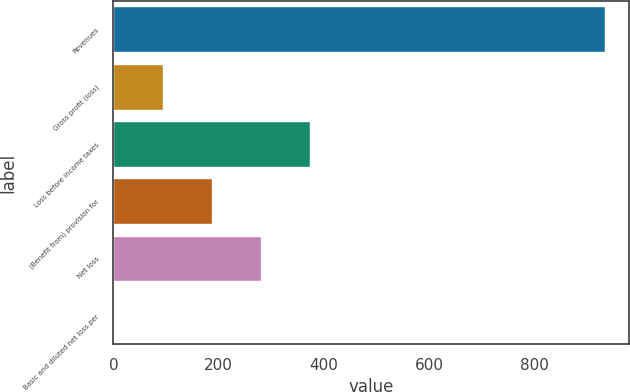<chart> <loc_0><loc_0><loc_500><loc_500><bar_chart><fcel>Revenues<fcel>Gross profit (loss)<fcel>Loss before income taxes<fcel>(Benefit from) provision for<fcel>Net loss<fcel>Basic and diluted net loss per<nl><fcel>932.9<fcel>93.7<fcel>373.44<fcel>186.94<fcel>280.19<fcel>0.45<nl></chart> 